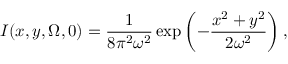Convert formula to latex. <formula><loc_0><loc_0><loc_500><loc_500>I ( x , y , \Omega , 0 ) = \frac { 1 } { 8 \pi ^ { 2 } \omega ^ { 2 } } \exp \left ( - \frac { x ^ { 2 } + y ^ { 2 } } { 2 \omega ^ { 2 } } \right ) ,</formula> 